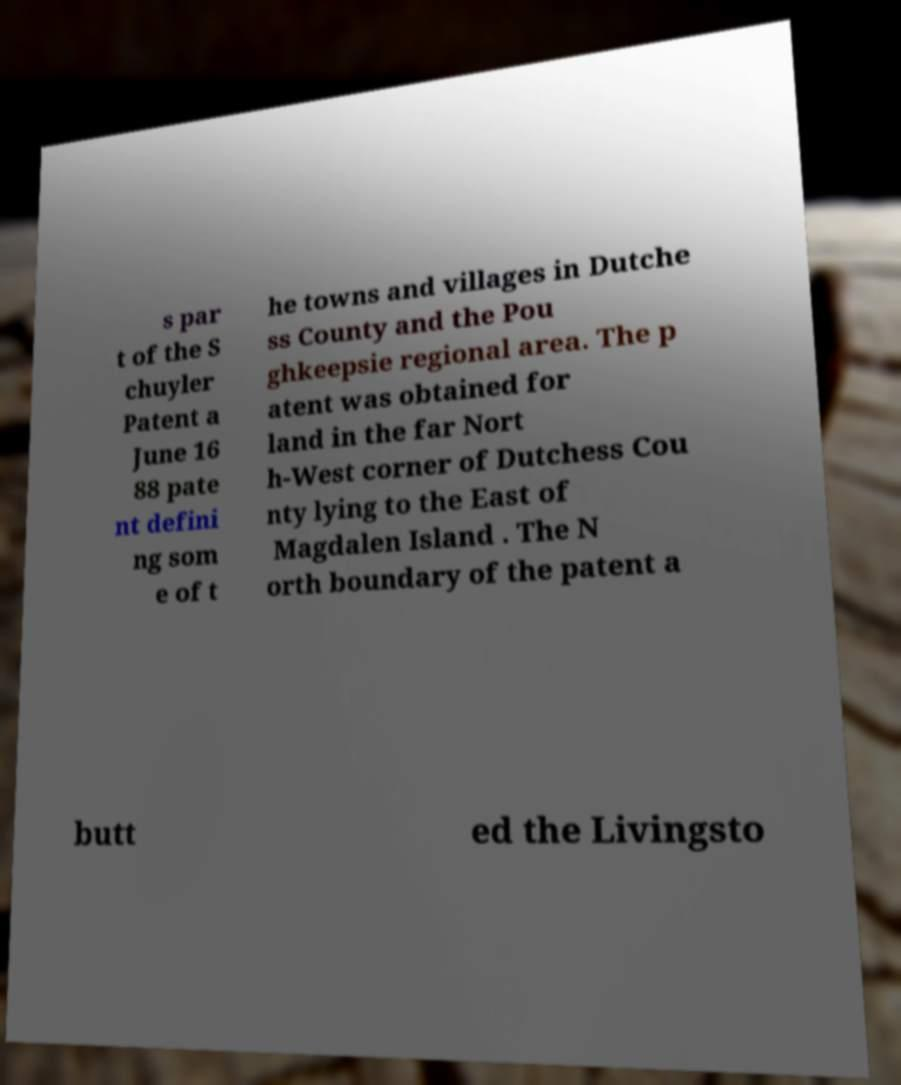Can you accurately transcribe the text from the provided image for me? s par t of the S chuyler Patent a June 16 88 pate nt defini ng som e of t he towns and villages in Dutche ss County and the Pou ghkeepsie regional area. The p atent was obtained for land in the far Nort h-West corner of Dutchess Cou nty lying to the East of Magdalen Island . The N orth boundary of the patent a butt ed the Livingsto 